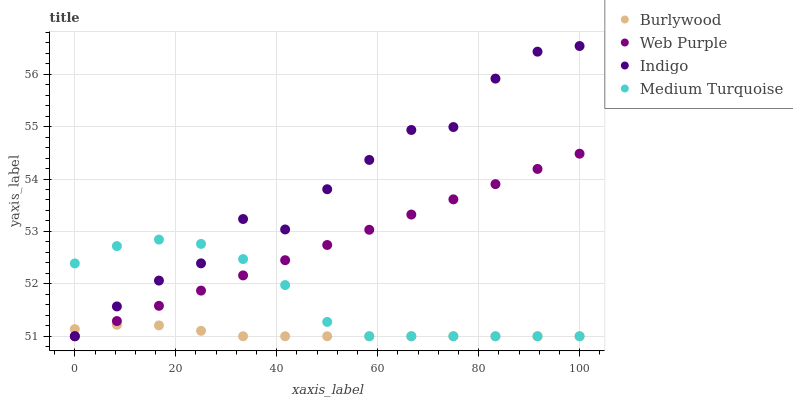Does Burlywood have the minimum area under the curve?
Answer yes or no. Yes. Does Indigo have the maximum area under the curve?
Answer yes or no. Yes. Does Web Purple have the minimum area under the curve?
Answer yes or no. No. Does Web Purple have the maximum area under the curve?
Answer yes or no. No. Is Web Purple the smoothest?
Answer yes or no. Yes. Is Indigo the roughest?
Answer yes or no. Yes. Is Indigo the smoothest?
Answer yes or no. No. Is Web Purple the roughest?
Answer yes or no. No. Does Burlywood have the lowest value?
Answer yes or no. Yes. Does Indigo have the highest value?
Answer yes or no. Yes. Does Web Purple have the highest value?
Answer yes or no. No. Does Web Purple intersect Medium Turquoise?
Answer yes or no. Yes. Is Web Purple less than Medium Turquoise?
Answer yes or no. No. Is Web Purple greater than Medium Turquoise?
Answer yes or no. No. 